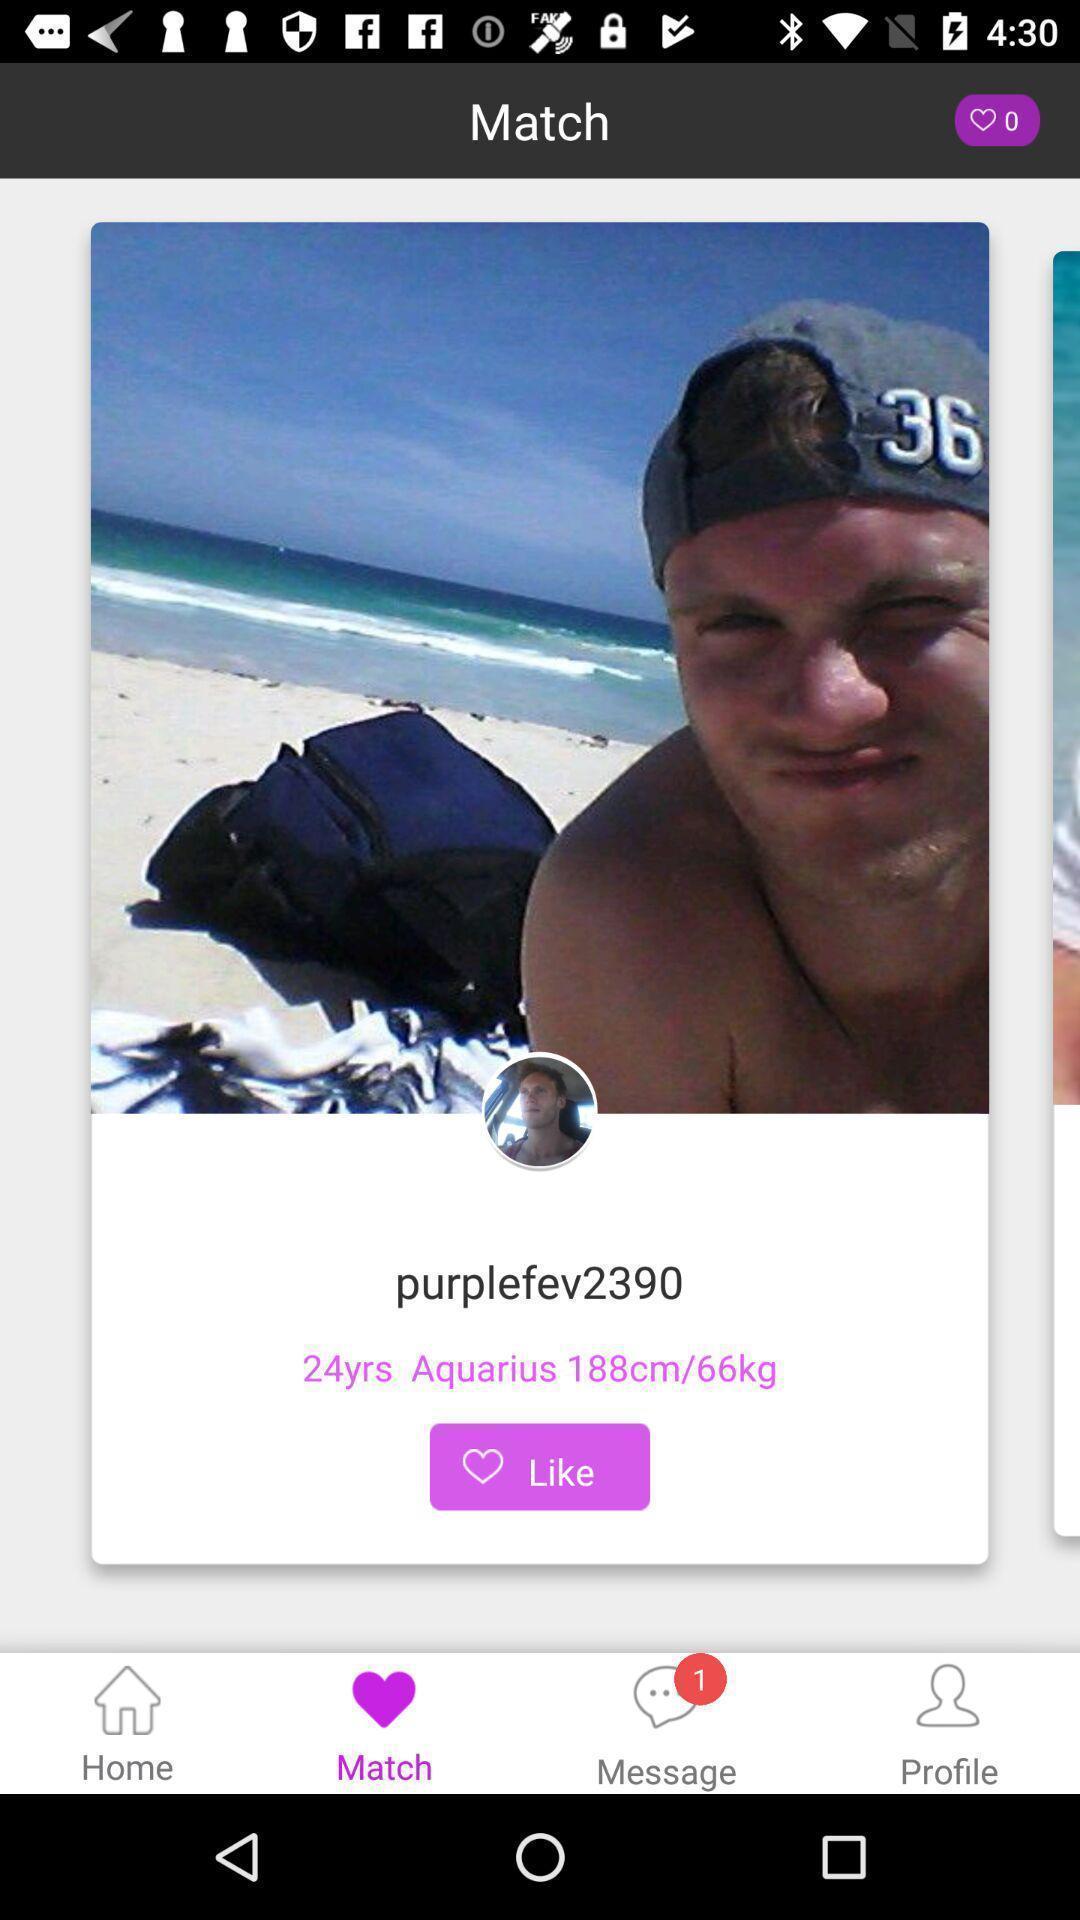Explain the elements present in this screenshot. Screen displaying the page of a social app. 